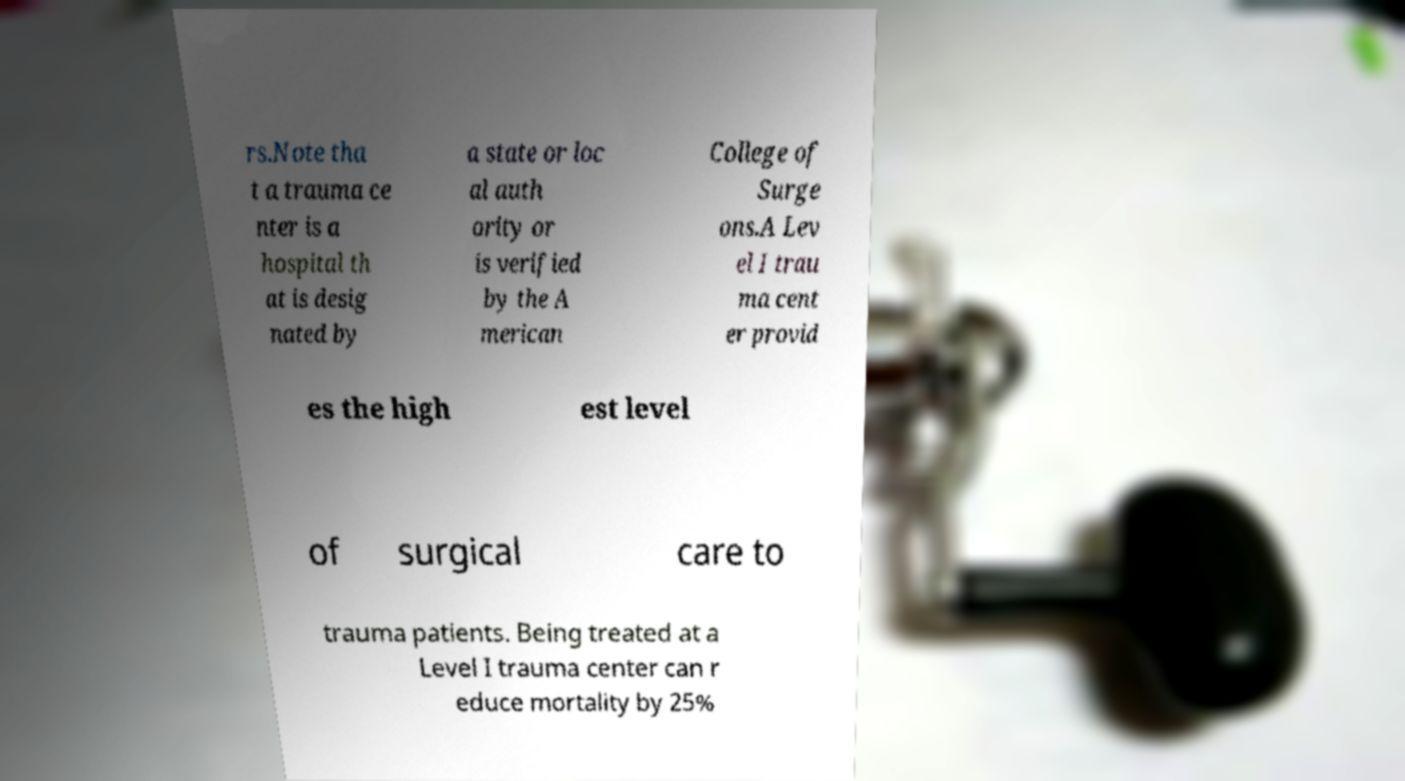Please read and relay the text visible in this image. What does it say? rs.Note tha t a trauma ce nter is a hospital th at is desig nated by a state or loc al auth ority or is verified by the A merican College of Surge ons.A Lev el I trau ma cent er provid es the high est level of surgical care to trauma patients. Being treated at a Level I trauma center can r educe mortality by 25% 